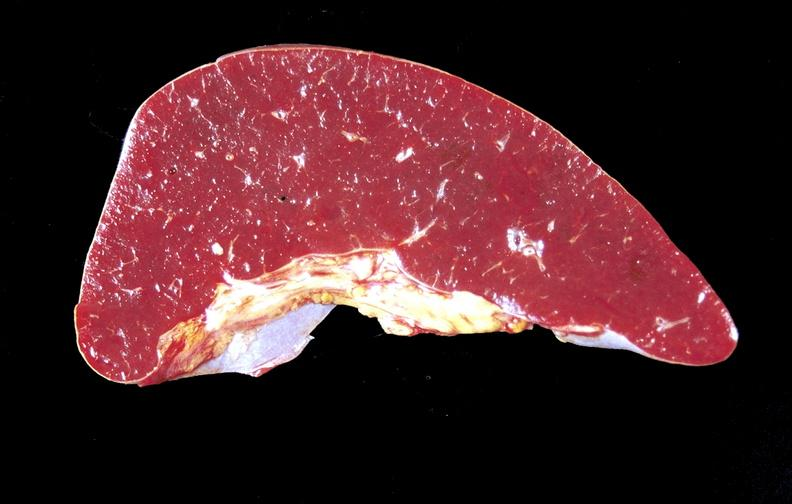what does this image show?
Answer the question using a single word or phrase. Amyloid 